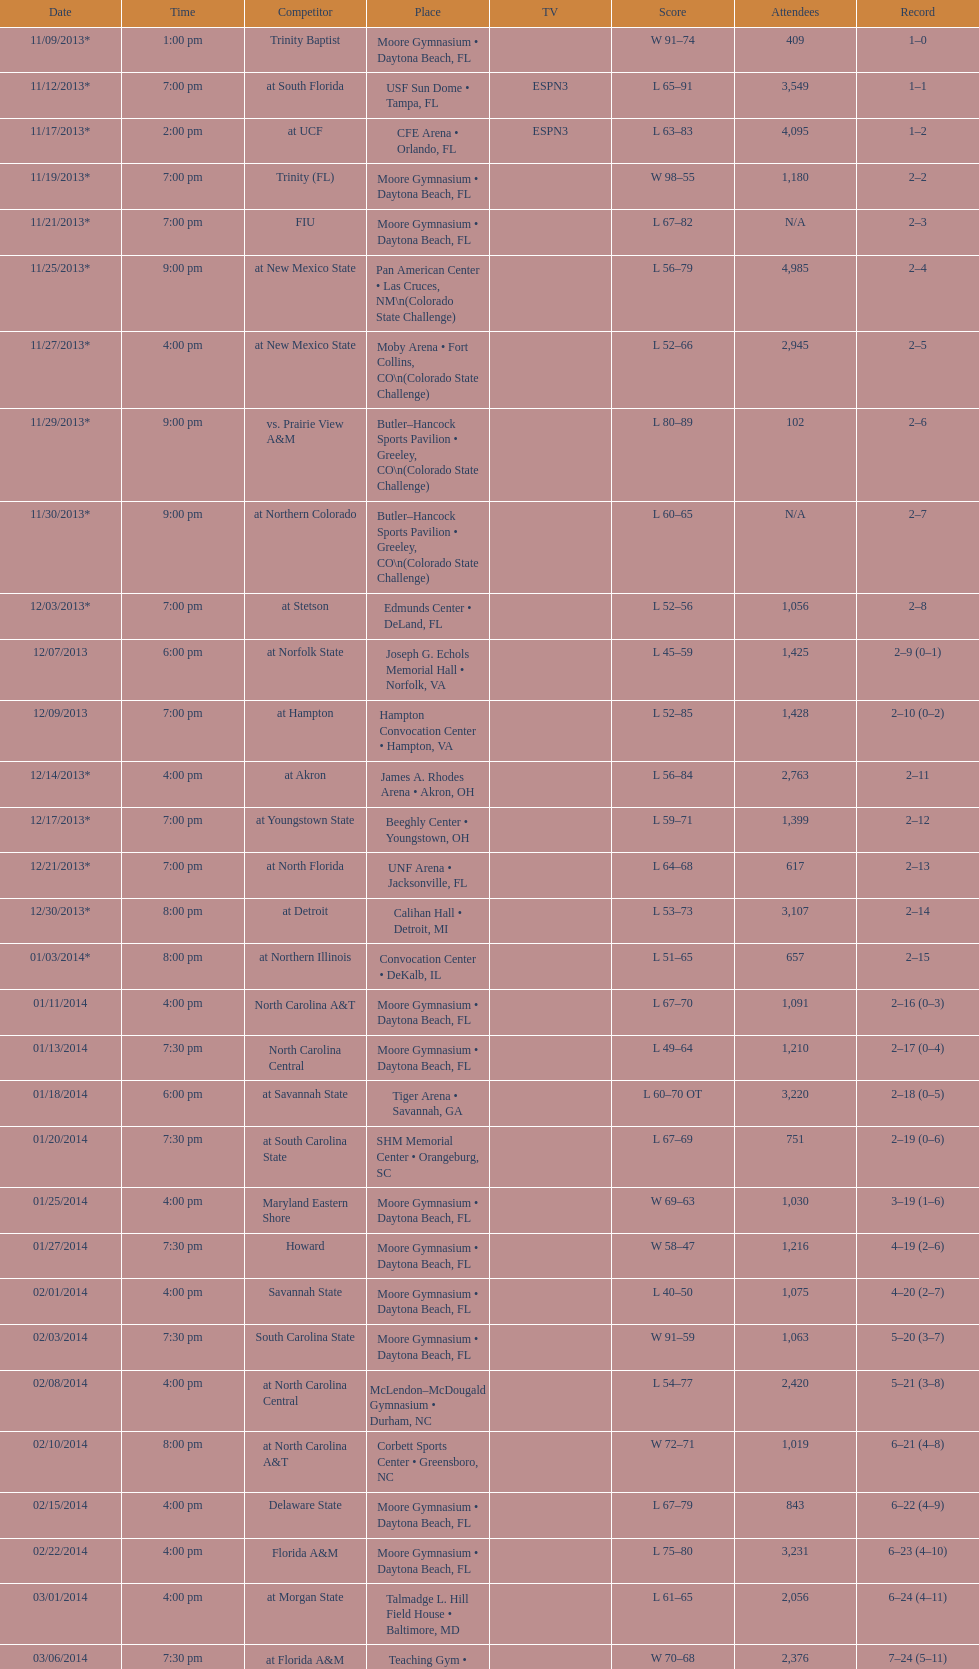Was the attendance of the game held on 11/19/2013 greater than 1,000? Yes. 